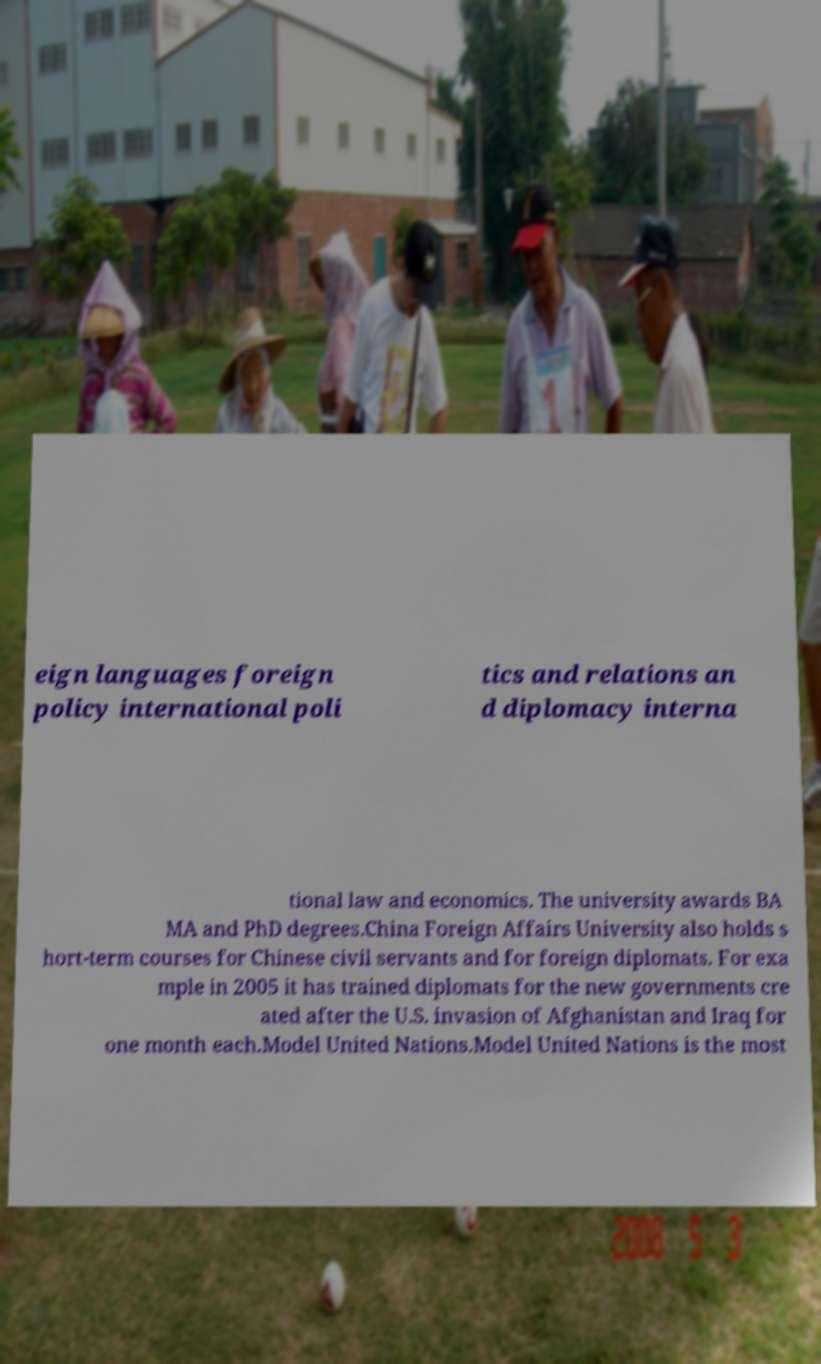Can you accurately transcribe the text from the provided image for me? eign languages foreign policy international poli tics and relations an d diplomacy interna tional law and economics. The university awards BA MA and PhD degrees.China Foreign Affairs University also holds s hort-term courses for Chinese civil servants and for foreign diplomats. For exa mple in 2005 it has trained diplomats for the new governments cre ated after the U.S. invasion of Afghanistan and Iraq for one month each.Model United Nations.Model United Nations is the most 